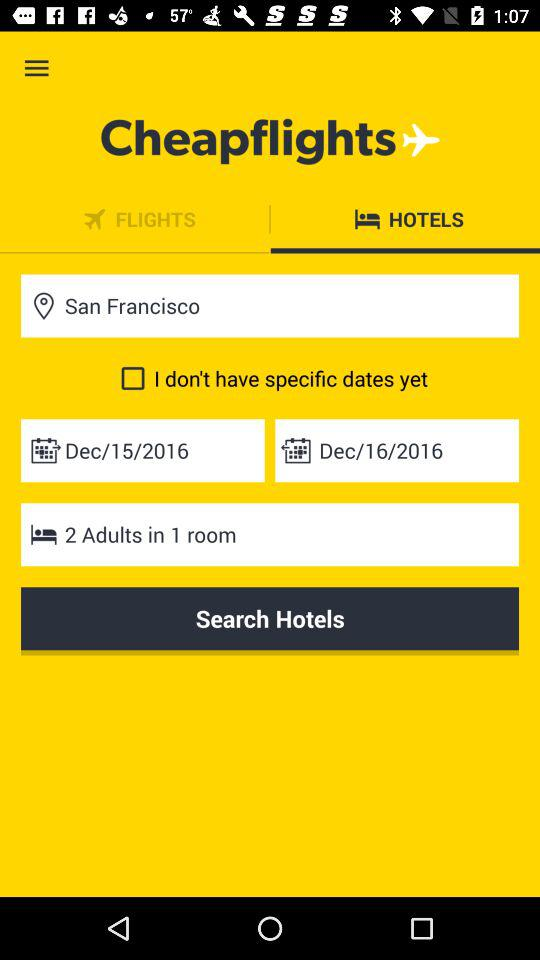What is the application name? The application name is "Cheapflights". 